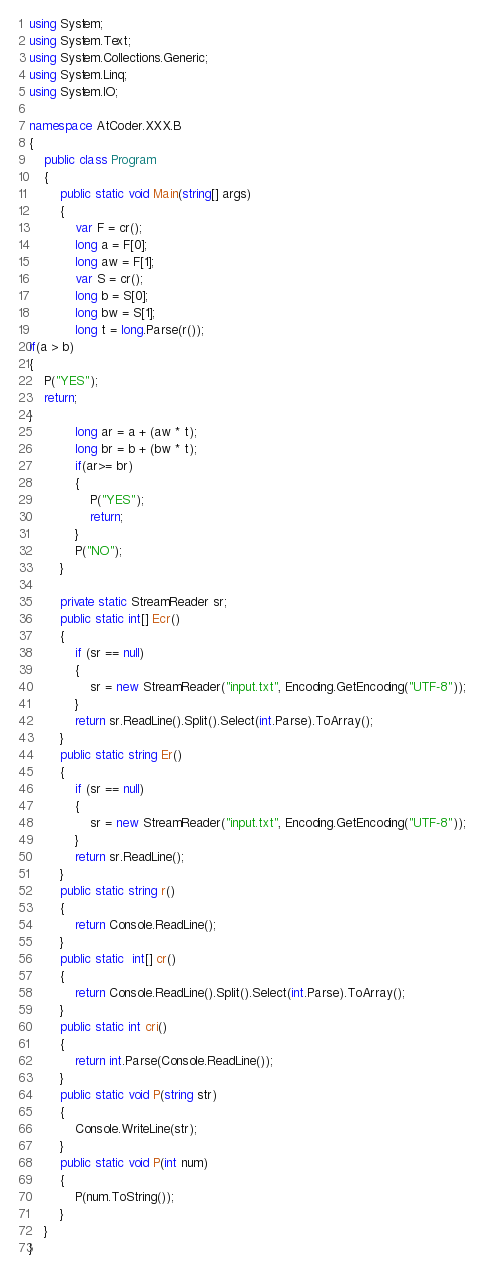<code> <loc_0><loc_0><loc_500><loc_500><_C#_>using System;
using System.Text;
using System.Collections.Generic;
using System.Linq;
using System.IO;

namespace AtCoder.XXX.B
{ 
    public class Program
    {
        public static void Main(string[] args)
        {
            var F = cr();
            long a = F[0];
            long aw = F[1];
            var S = cr();
            long b = S[0];
            long bw = S[1];
            long t = long.Parse(r());
if(a > b)
{
    P("YES");
    return;
}
            long ar = a + (aw * t); 
            long br = b + (bw * t);
            if(ar>= br)
			{
                P("YES");
                return;
			}
            P("NO");
        }

        private static StreamReader sr;
        public static int[] Ecr()
        {
            if (sr == null)
            {
                sr = new StreamReader("input.txt", Encoding.GetEncoding("UTF-8"));
            }
            return sr.ReadLine().Split().Select(int.Parse).ToArray();
        }
        public static string Er()
        {
            if (sr == null)
            {
                sr = new StreamReader("input.txt", Encoding.GetEncoding("UTF-8"));
            }
            return sr.ReadLine();
        }
        public static string r()
        {
            return Console.ReadLine();
        }
        public static  int[] cr()
        {
            return Console.ReadLine().Split().Select(int.Parse).ToArray();
        }
        public static int cri()
        {
            return int.Parse(Console.ReadLine());
        }
        public static void P(string str)
        {
            Console.WriteLine(str);
        }
        public static void P(int num)
        {
            P(num.ToString());
        }
    }
}
</code> 